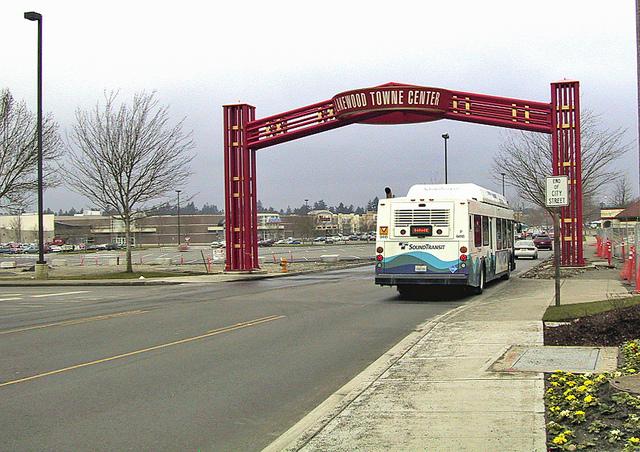Is this a parking lot?
Be succinct. No. What information does the red sign provide?
Give a very brief answer. Lakewood towne center. What color is the gate?
Concise answer only. Red. Where is the picture taken of the camper?
Give a very brief answer. Towne center. What establishment is the bus entering?
Concise answer only. Town center. What state is this picture taken based on the sign?
Keep it brief. Illinois. What is the sidewalk made of?
Be succinct. Concrete. 